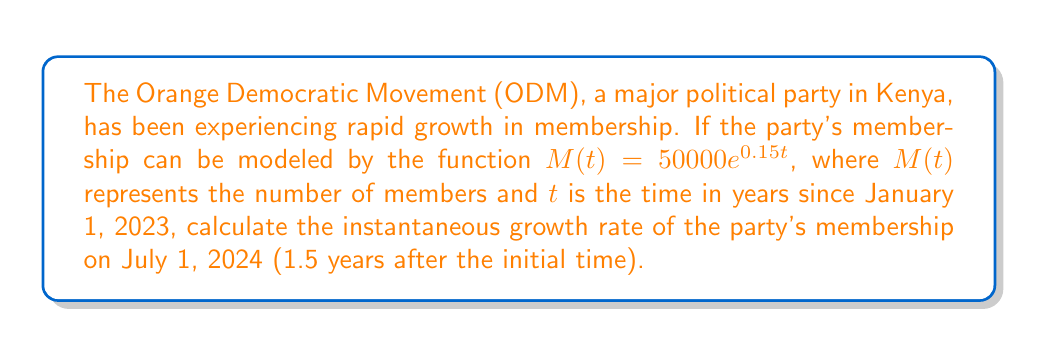Give your solution to this math problem. To solve this problem, we'll follow these steps:

1) The instantaneous growth rate is given by the derivative of the function at the specified time.

2) First, let's find the derivative of $M(t)$:
   $$\frac{d}{dt}M(t) = \frac{d}{dt}(50000e^{0.15t}) = 50000 \cdot 0.15e^{0.15t} = 7500e^{0.15t}$$

3) Now, we need to evaluate this derivative at $t = 1.5$ years:
   $$\frac{d}{dt}M(1.5) = 7500e^{0.15(1.5)} = 7500e^{0.225}$$

4) Using a calculator or computer to evaluate this expression:
   $$7500e^{0.225} \approx 9453.66$$

5) This result represents the instantaneous growth rate in members per year.

6) To interpret this in the context of Kenyan politics, we can say that on July 1, 2024, the ODM party's membership is growing at a rate of approximately 9,454 new members per year.
Answer: 9,454 members per year 